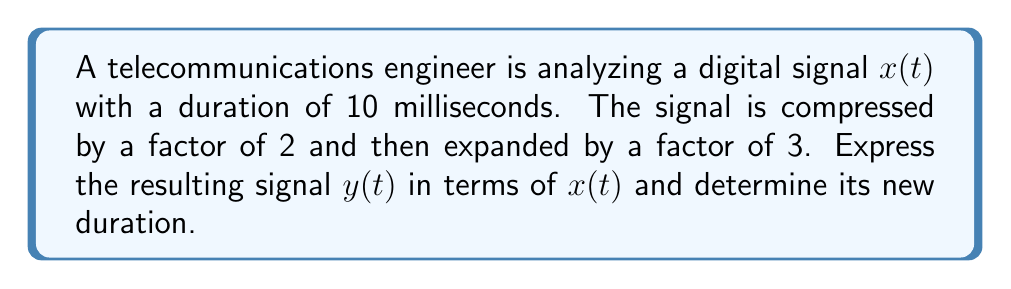Solve this math problem. Let's approach this step-by-step:

1) First, we need to understand the effects of compression and expansion on a signal:
   - Compression by a factor of $a$ transforms $x(t)$ to $x(at)$
   - Expansion by a factor of $b$ transforms $x(t)$ to $x(t/b)$

2) In this case, we first compress by a factor of 2:
   $x(t) \rightarrow x(2t)$

3) Then we expand the compressed signal by a factor of 3:
   $x(2t) \rightarrow x(2t/3)$

4) Therefore, the resulting signal $y(t)$ can be expressed as:
   $y(t) = x(2t/3)$

5) To find the new duration, we need to consider how these transformations affect the time scale:
   - Compression by 2 halves the duration: 10 ms $\rightarrow$ 5 ms
   - Expansion by 3 triples the duration: 5 ms $\rightarrow$ 15 ms

6) Thus, the new duration is 15 milliseconds.
Answer: $y(t) = x(2t/3)$; 15 ms 